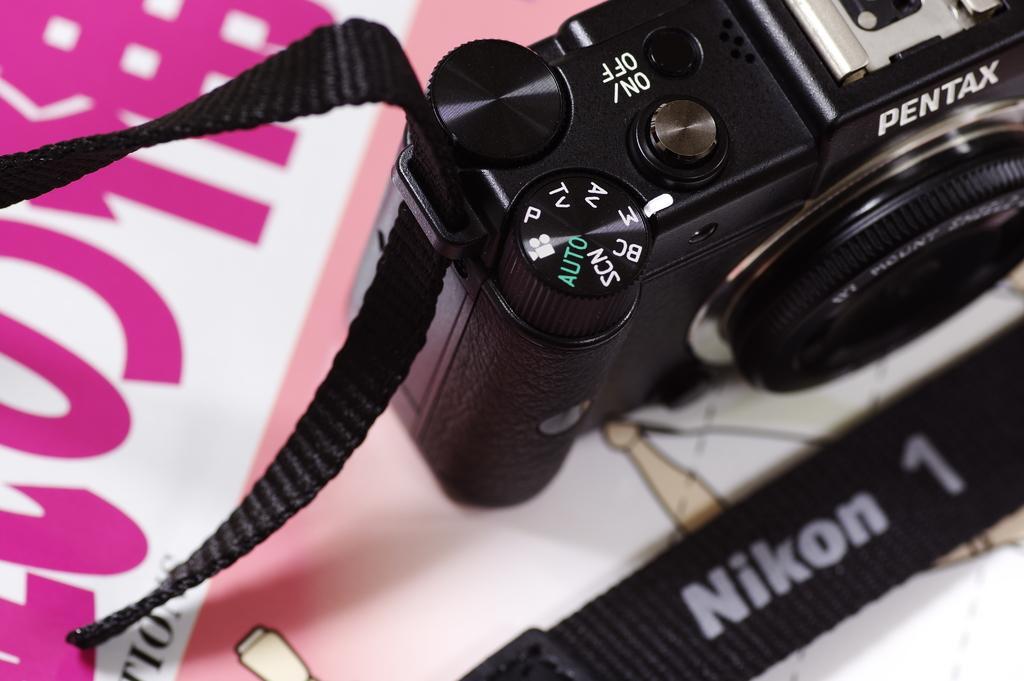Could you give a brief overview of what you see in this image? In this picture I can see a camera on an object. 